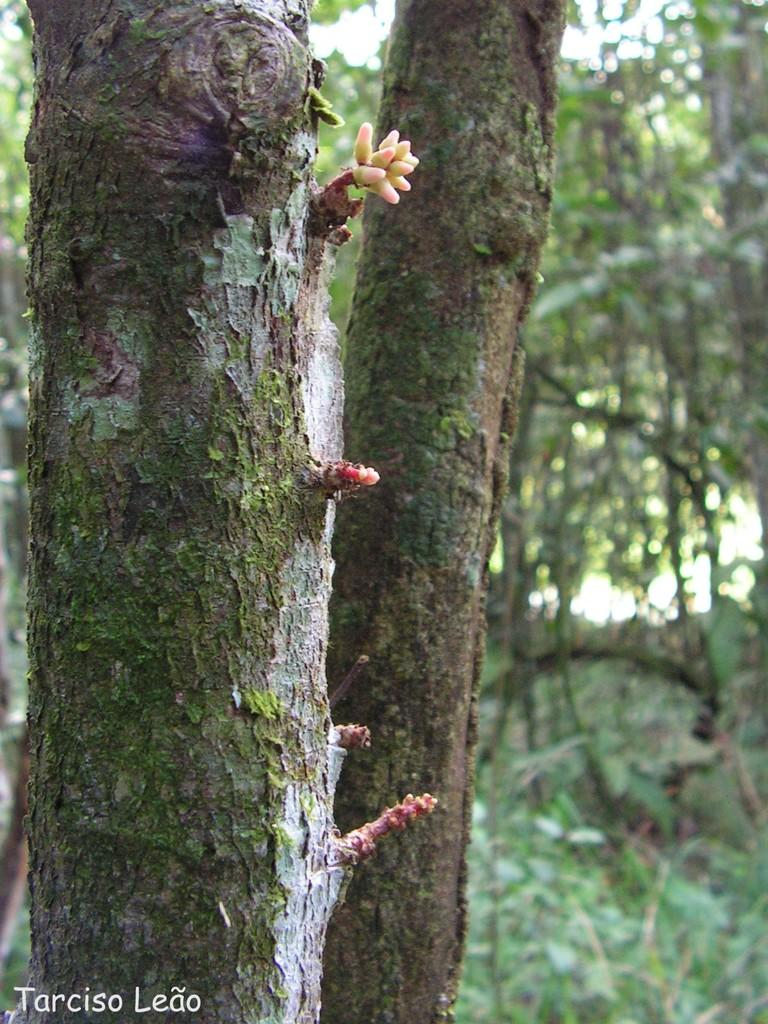What type of vegetation can be seen in the image? There are trees in the image. How many dinosaurs can be seen among the trees in the image? There are no dinosaurs present in the image; it only features trees. What type of ear is visible on the tree trunk in the image? There is no ear visible in the image, as it only features trees and does not include any animals or human-like features. 